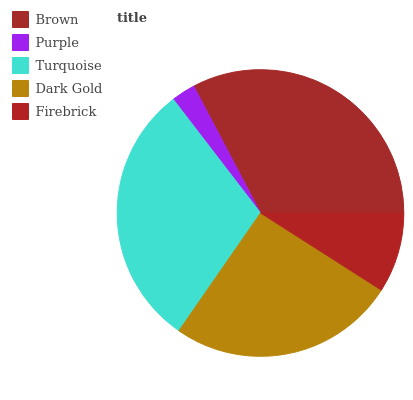Is Purple the minimum?
Answer yes or no. Yes. Is Brown the maximum?
Answer yes or no. Yes. Is Turquoise the minimum?
Answer yes or no. No. Is Turquoise the maximum?
Answer yes or no. No. Is Turquoise greater than Purple?
Answer yes or no. Yes. Is Purple less than Turquoise?
Answer yes or no. Yes. Is Purple greater than Turquoise?
Answer yes or no. No. Is Turquoise less than Purple?
Answer yes or no. No. Is Dark Gold the high median?
Answer yes or no. Yes. Is Dark Gold the low median?
Answer yes or no. Yes. Is Firebrick the high median?
Answer yes or no. No. Is Purple the low median?
Answer yes or no. No. 